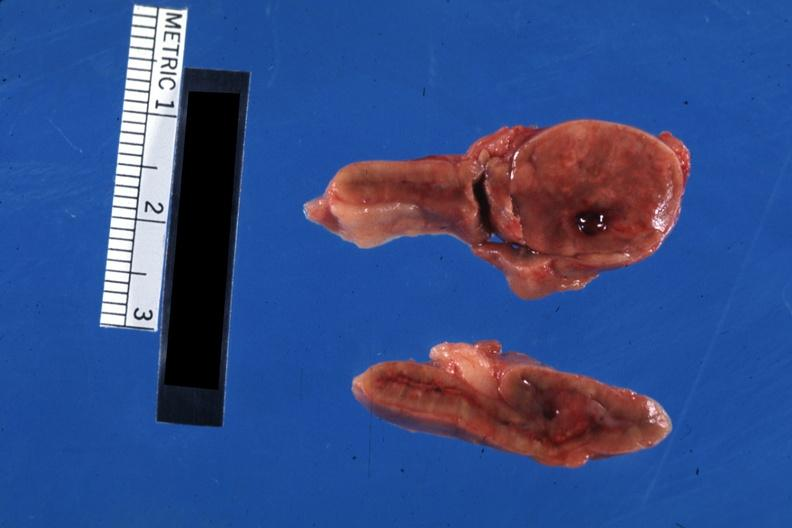s adrenal present?
Answer the question using a single word or phrase. Yes 